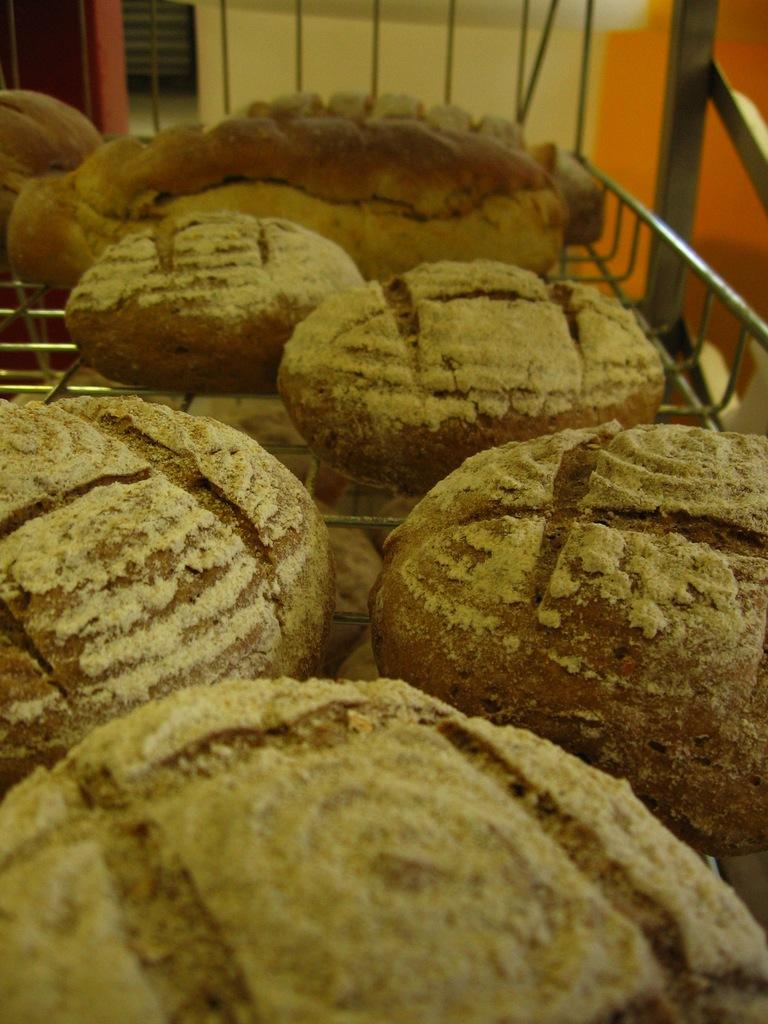What is the main object in the image? There is a metal grill in the image. What is placed on the metal grill? There are cookies on the metal grill. What can be seen in the background of the image? There is a wall visible in the background of the image. What type of shock can be seen affecting the cookies on the metal grill? There is no shock present in the image; the cookies are simply placed on the metal grill. 